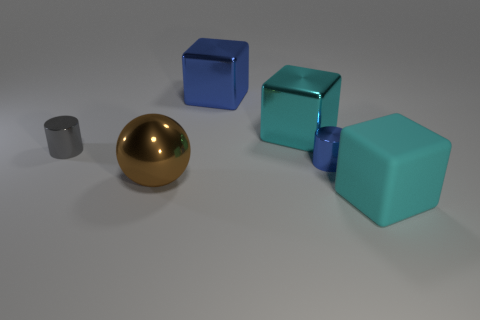Add 3 red cubes. How many objects exist? 9 Subtract all cyan blocks. How many blocks are left? 1 Subtract all purple cylinders. How many cyan blocks are left? 2 Subtract all balls. How many objects are left? 5 Add 6 cyan rubber objects. How many cyan rubber objects are left? 7 Add 3 cyan blocks. How many cyan blocks exist? 5 Subtract all cyan blocks. How many blocks are left? 1 Subtract 1 blue cylinders. How many objects are left? 5 Subtract 2 cubes. How many cubes are left? 1 Subtract all gray cylinders. Subtract all brown balls. How many cylinders are left? 1 